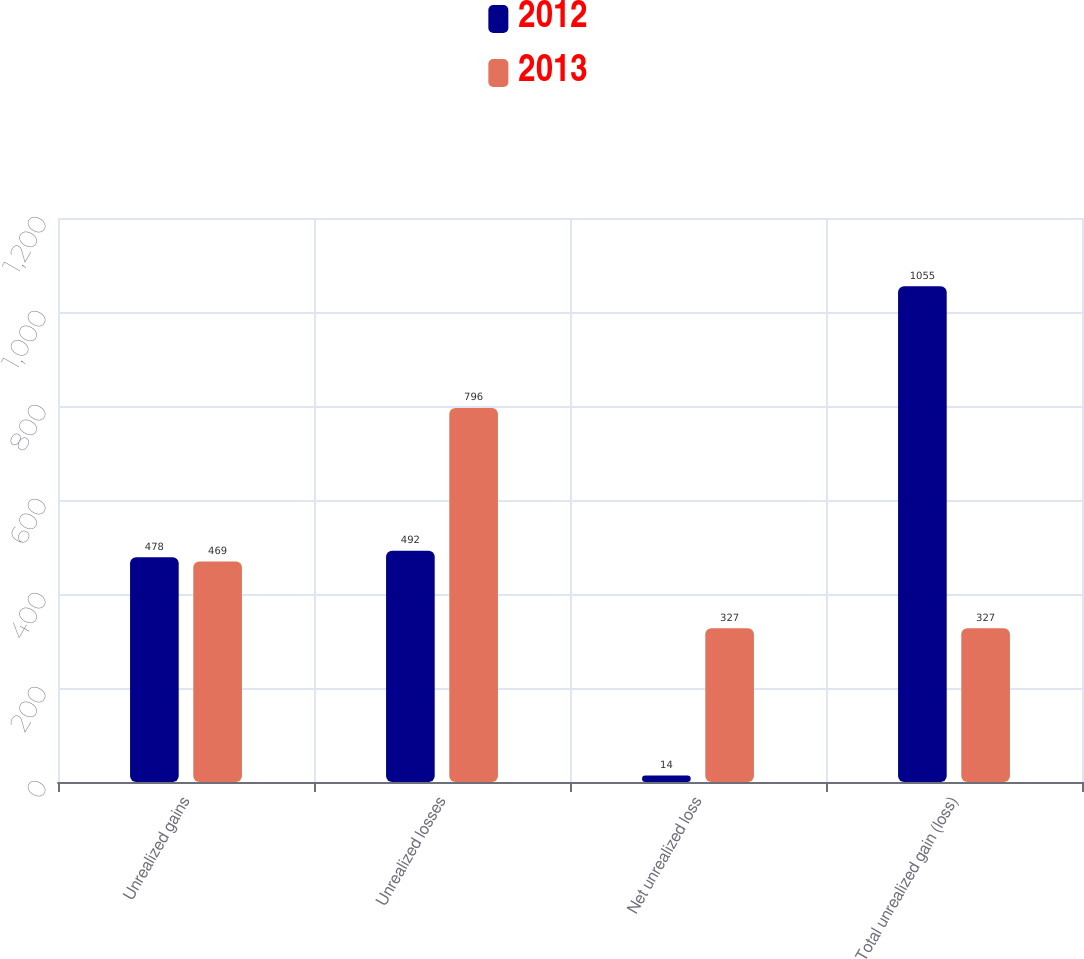Convert chart. <chart><loc_0><loc_0><loc_500><loc_500><stacked_bar_chart><ecel><fcel>Unrealized gains<fcel>Unrealized losses<fcel>Net unrealized loss<fcel>Total unrealized gain (loss)<nl><fcel>2012<fcel>478<fcel>492<fcel>14<fcel>1055<nl><fcel>2013<fcel>469<fcel>796<fcel>327<fcel>327<nl></chart> 